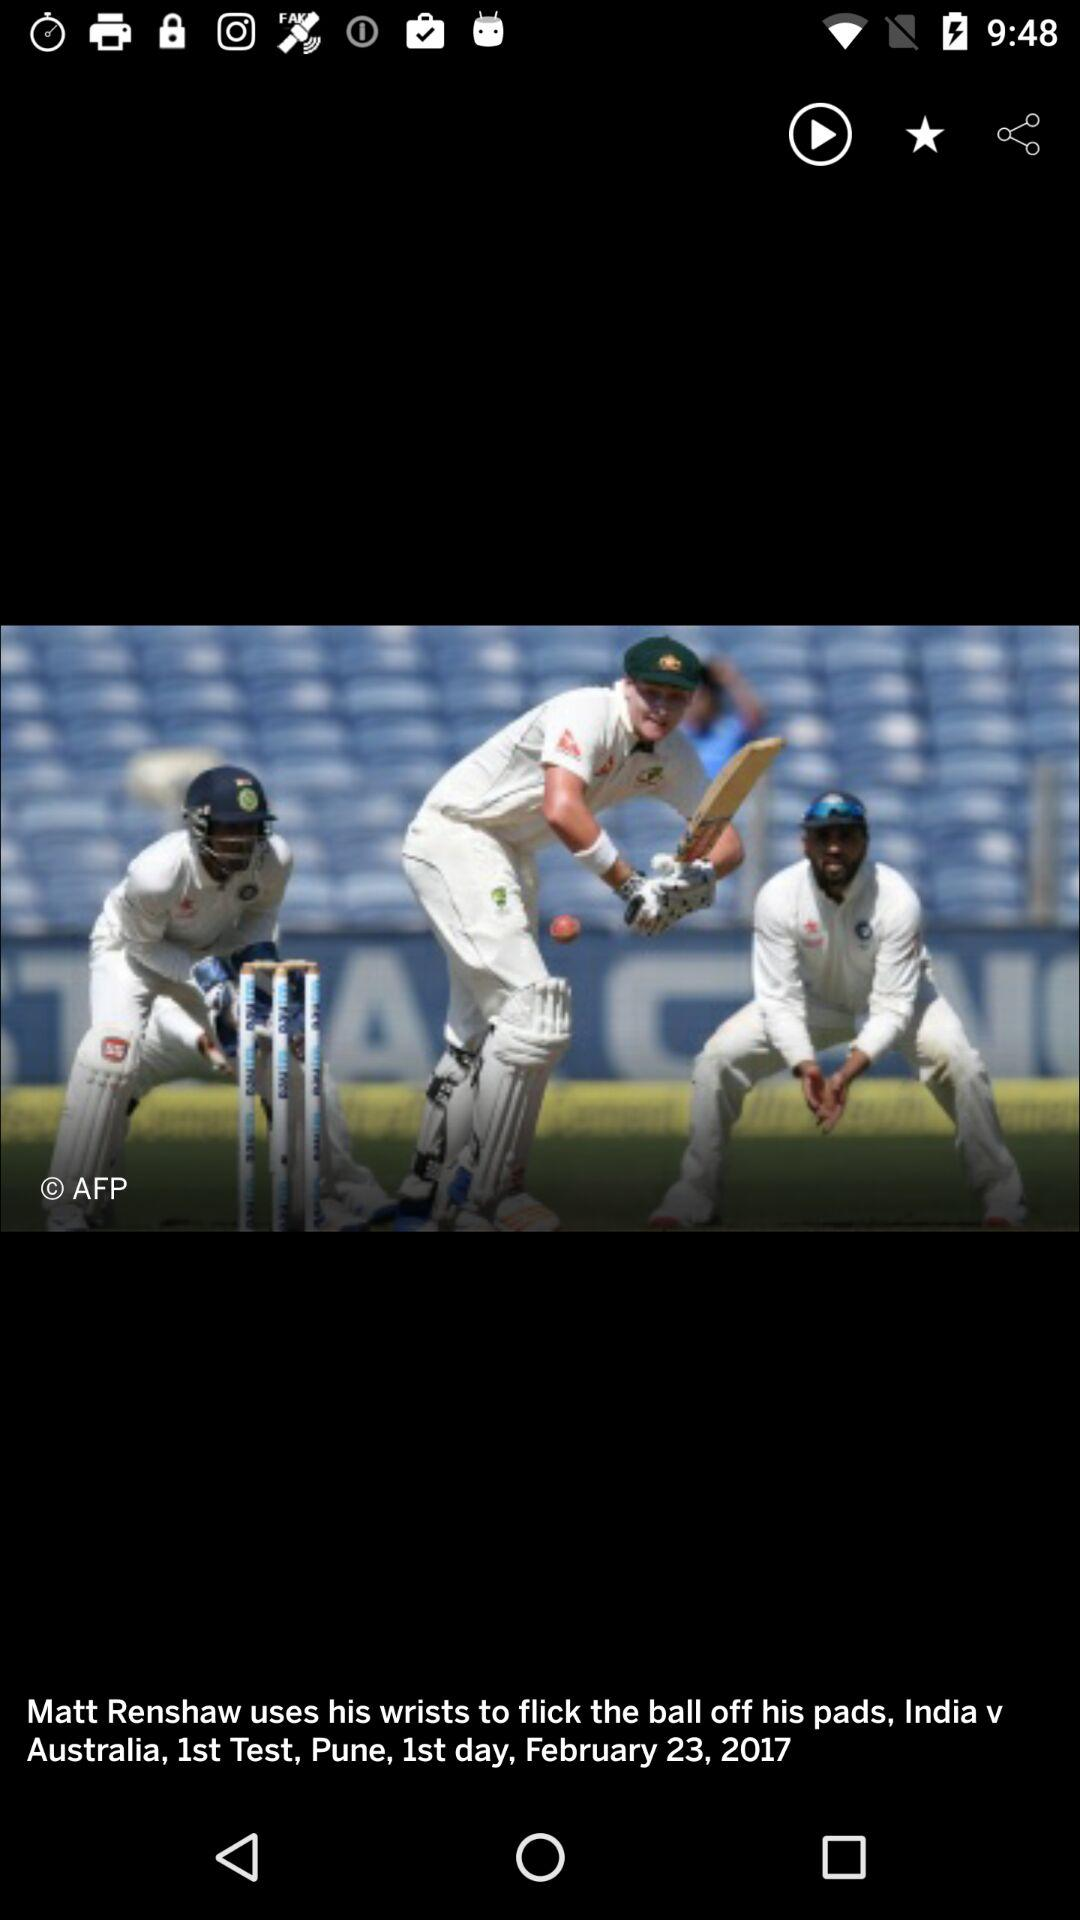Between which teams is the match? The match is between "India" and "Australia". 